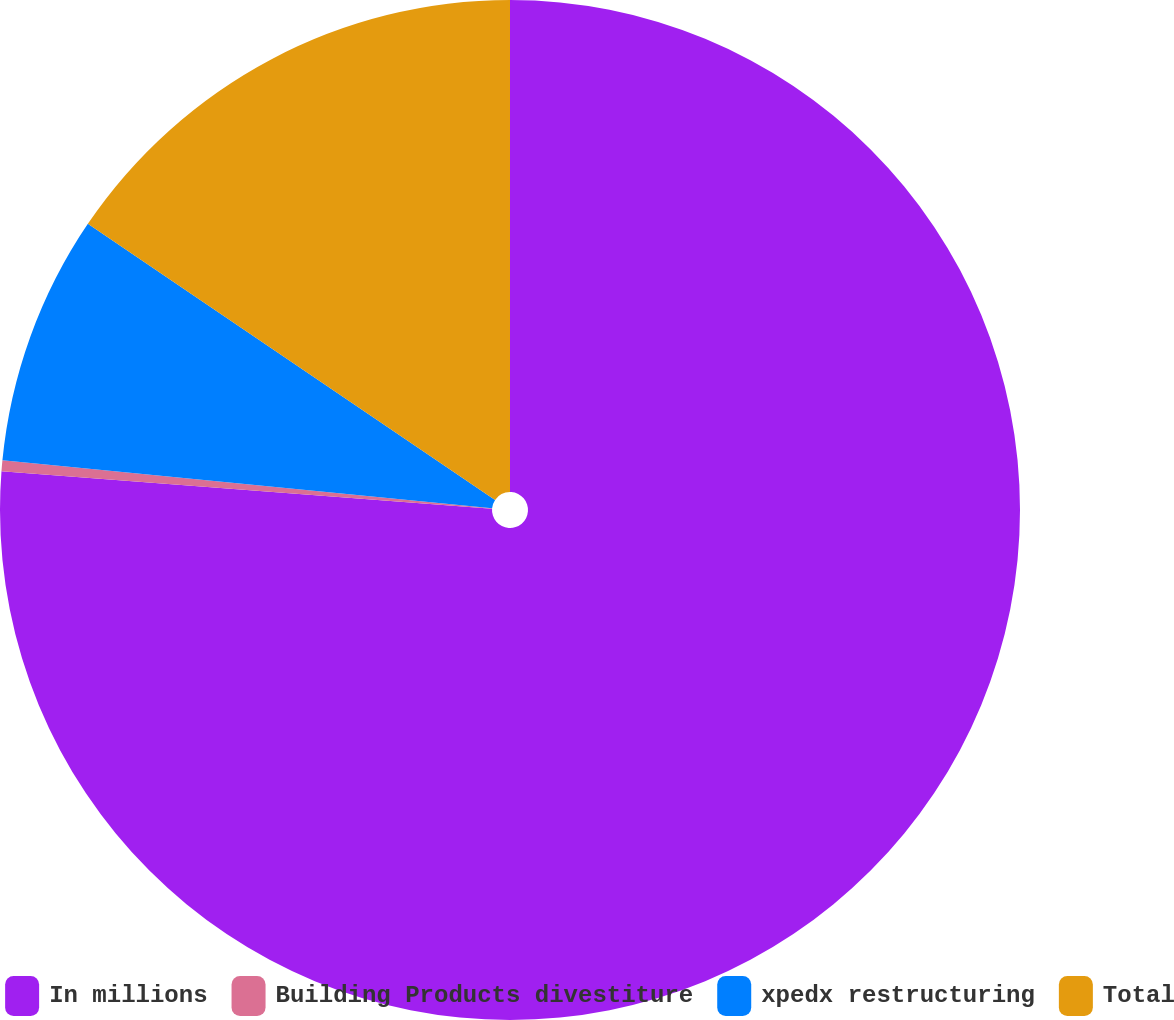<chart> <loc_0><loc_0><loc_500><loc_500><pie_chart><fcel>In millions<fcel>Building Products divestiture<fcel>xpedx restructuring<fcel>Total<nl><fcel>76.22%<fcel>0.34%<fcel>7.93%<fcel>15.52%<nl></chart> 